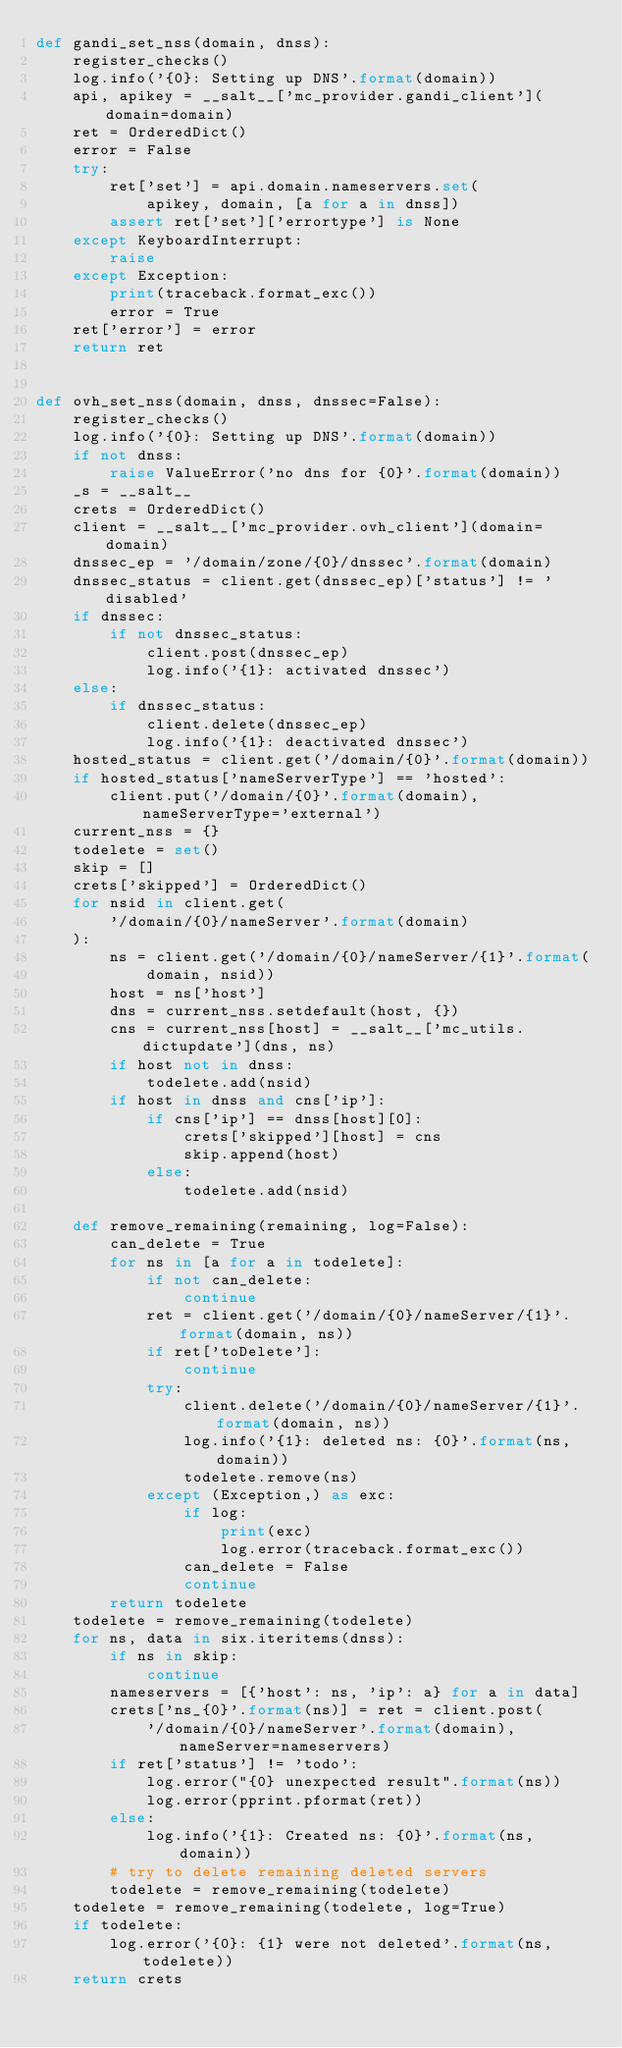<code> <loc_0><loc_0><loc_500><loc_500><_Python_>def gandi_set_nss(domain, dnss):
    register_checks()
    log.info('{0}: Setting up DNS'.format(domain))
    api, apikey = __salt__['mc_provider.gandi_client'](domain=domain)
    ret = OrderedDict()
    error = False
    try:
        ret['set'] = api.domain.nameservers.set(
            apikey, domain, [a for a in dnss])
        assert ret['set']['errortype'] is None
    except KeyboardInterrupt:
        raise
    except Exception:
        print(traceback.format_exc())
        error = True
    ret['error'] = error
    return ret


def ovh_set_nss(domain, dnss, dnssec=False):
    register_checks()
    log.info('{0}: Setting up DNS'.format(domain))
    if not dnss:
        raise ValueError('no dns for {0}'.format(domain))
    _s = __salt__
    crets = OrderedDict()
    client = __salt__['mc_provider.ovh_client'](domain=domain)
    dnssec_ep = '/domain/zone/{0}/dnssec'.format(domain)
    dnssec_status = client.get(dnssec_ep)['status'] != 'disabled'
    if dnssec:
        if not dnssec_status:
            client.post(dnssec_ep)
            log.info('{1}: activated dnssec')
    else:
        if dnssec_status:
            client.delete(dnssec_ep)
            log.info('{1}: deactivated dnssec')
    hosted_status = client.get('/domain/{0}'.format(domain))
    if hosted_status['nameServerType'] == 'hosted':
        client.put('/domain/{0}'.format(domain), nameServerType='external')
    current_nss = {}
    todelete = set()
    skip = []
    crets['skipped'] = OrderedDict()
    for nsid in client.get(
        '/domain/{0}/nameServer'.format(domain)
    ):
        ns = client.get('/domain/{0}/nameServer/{1}'.format(
            domain, nsid))
        host = ns['host']
        dns = current_nss.setdefault(host, {})
        cns = current_nss[host] = __salt__['mc_utils.dictupdate'](dns, ns)
        if host not in dnss:
            todelete.add(nsid)
        if host in dnss and cns['ip']:
            if cns['ip'] == dnss[host][0]:
                crets['skipped'][host] = cns
                skip.append(host)
            else:
                todelete.add(nsid)

    def remove_remaining(remaining, log=False):
        can_delete = True
        for ns in [a for a in todelete]:
            if not can_delete:
                continue
            ret = client.get('/domain/{0}/nameServer/{1}'.format(domain, ns))
            if ret['toDelete']:
                continue
            try:
                client.delete('/domain/{0}/nameServer/{1}'.format(domain, ns))
                log.info('{1}: deleted ns: {0}'.format(ns, domain))
                todelete.remove(ns)
            except (Exception,) as exc:
                if log:
                    print(exc)
                    log.error(traceback.format_exc())
                can_delete = False
                continue
        return todelete
    todelete = remove_remaining(todelete)
    for ns, data in six.iteritems(dnss):
        if ns in skip:
            continue
        nameservers = [{'host': ns, 'ip': a} for a in data]
        crets['ns_{0}'.format(ns)] = ret = client.post(
            '/domain/{0}/nameServer'.format(domain), nameServer=nameservers)
        if ret['status'] != 'todo':
            log.error("{0} unexpected result".format(ns))
            log.error(pprint.pformat(ret))
        else:
            log.info('{1}: Created ns: {0}'.format(ns, domain))
        # try to delete remaining deleted servers
        todelete = remove_remaining(todelete)
    todelete = remove_remaining(todelete, log=True)
    if todelete:
        log.error('{0}: {1} were not deleted'.format(ns, todelete))
    return crets

</code> 